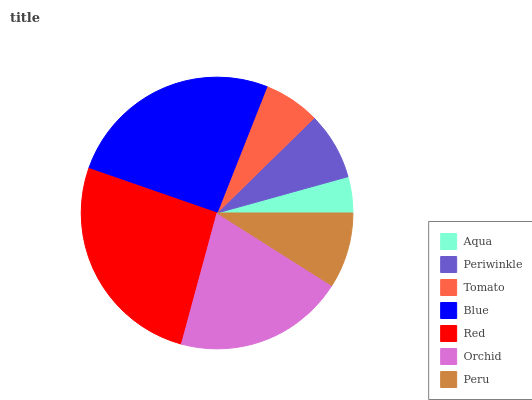Is Aqua the minimum?
Answer yes or no. Yes. Is Red the maximum?
Answer yes or no. Yes. Is Periwinkle the minimum?
Answer yes or no. No. Is Periwinkle the maximum?
Answer yes or no. No. Is Periwinkle greater than Aqua?
Answer yes or no. Yes. Is Aqua less than Periwinkle?
Answer yes or no. Yes. Is Aqua greater than Periwinkle?
Answer yes or no. No. Is Periwinkle less than Aqua?
Answer yes or no. No. Is Peru the high median?
Answer yes or no. Yes. Is Peru the low median?
Answer yes or no. Yes. Is Tomato the high median?
Answer yes or no. No. Is Orchid the low median?
Answer yes or no. No. 